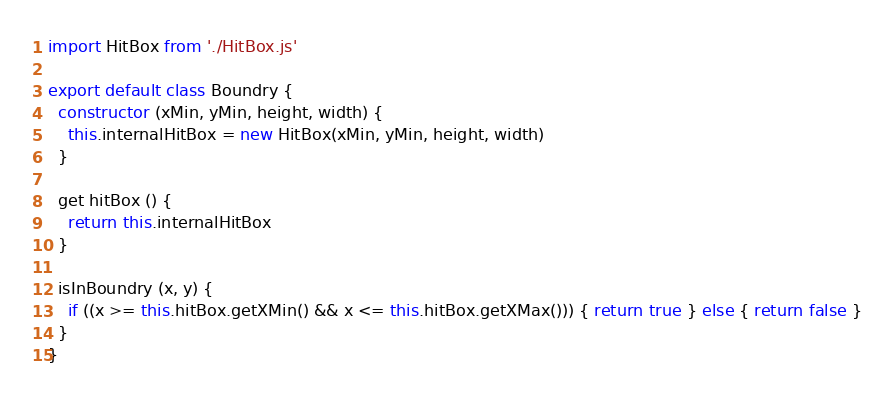<code> <loc_0><loc_0><loc_500><loc_500><_JavaScript_>import HitBox from './HitBox.js'

export default class Boundry {
  constructor (xMin, yMin, height, width) {
    this.internalHitBox = new HitBox(xMin, yMin, height, width)
  }

  get hitBox () {
    return this.internalHitBox
  }

  isInBoundry (x, y) {
    if ((x >= this.hitBox.getXMin() && x <= this.hitBox.getXMax())) { return true } else { return false }
  }
}
</code> 